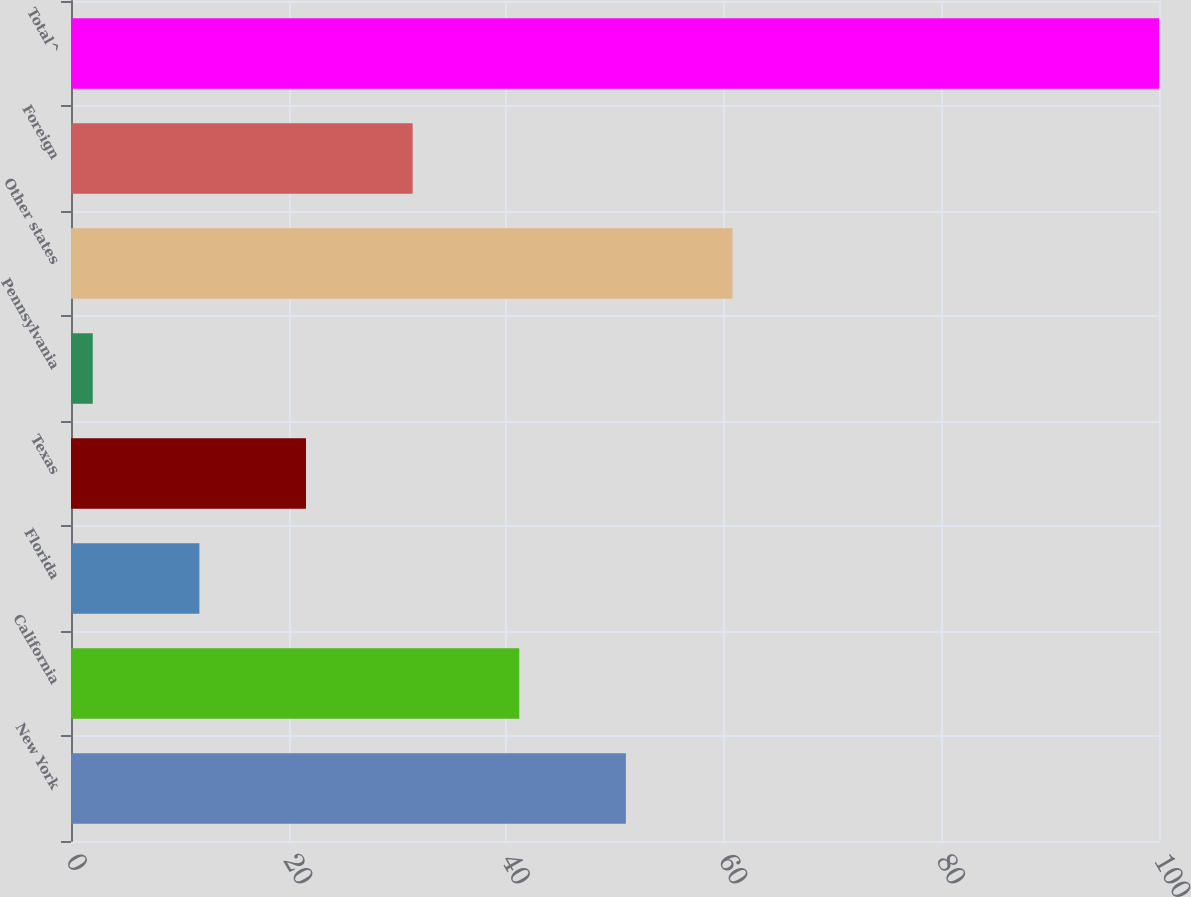Convert chart. <chart><loc_0><loc_0><loc_500><loc_500><bar_chart><fcel>New York<fcel>California<fcel>Florida<fcel>Texas<fcel>Pennsylvania<fcel>Other states<fcel>Foreign<fcel>Total^<nl><fcel>51<fcel>41.2<fcel>11.8<fcel>21.6<fcel>2<fcel>60.8<fcel>31.4<fcel>100<nl></chart> 